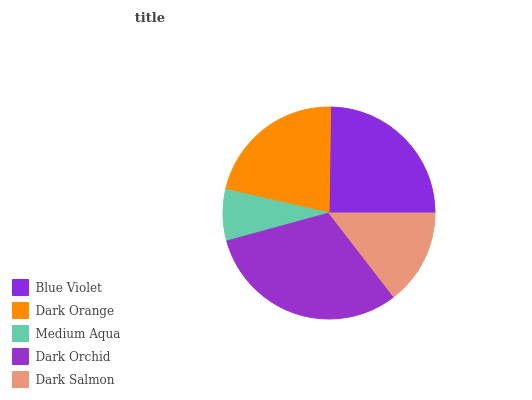Is Medium Aqua the minimum?
Answer yes or no. Yes. Is Dark Orchid the maximum?
Answer yes or no. Yes. Is Dark Orange the minimum?
Answer yes or no. No. Is Dark Orange the maximum?
Answer yes or no. No. Is Blue Violet greater than Dark Orange?
Answer yes or no. Yes. Is Dark Orange less than Blue Violet?
Answer yes or no. Yes. Is Dark Orange greater than Blue Violet?
Answer yes or no. No. Is Blue Violet less than Dark Orange?
Answer yes or no. No. Is Dark Orange the high median?
Answer yes or no. Yes. Is Dark Orange the low median?
Answer yes or no. Yes. Is Dark Orchid the high median?
Answer yes or no. No. Is Blue Violet the low median?
Answer yes or no. No. 